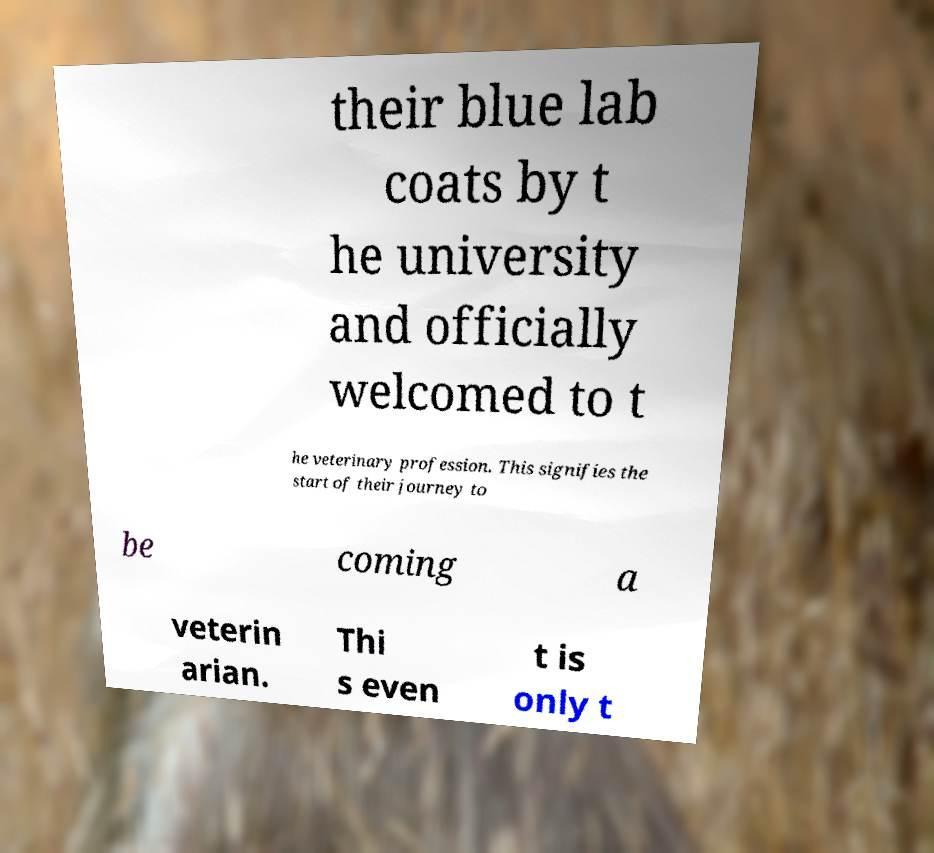Can you read and provide the text displayed in the image?This photo seems to have some interesting text. Can you extract and type it out for me? their blue lab coats by t he university and officially welcomed to t he veterinary profession. This signifies the start of their journey to be coming a veterin arian. Thi s even t is only t 